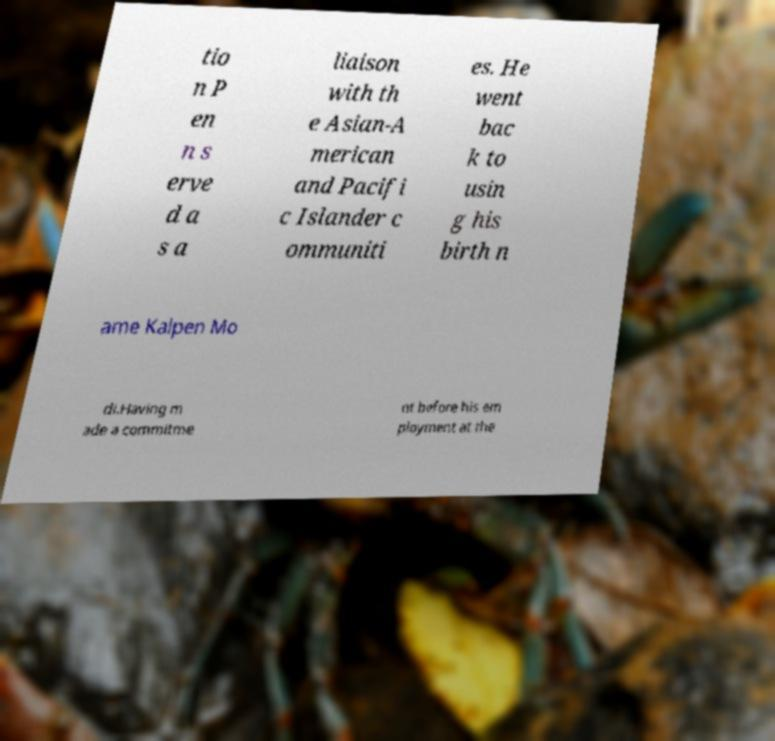I need the written content from this picture converted into text. Can you do that? tio n P en n s erve d a s a liaison with th e Asian-A merican and Pacifi c Islander c ommuniti es. He went bac k to usin g his birth n ame Kalpen Mo di.Having m ade a commitme nt before his em ployment at the 